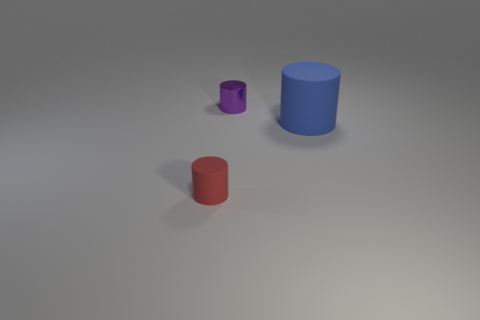Subtract all small shiny cylinders. How many cylinders are left? 2 Add 3 red rubber things. How many objects exist? 6 Subtract all brown cylinders. Subtract all yellow spheres. How many cylinders are left? 3 Add 1 tiny metallic cylinders. How many tiny metallic cylinders exist? 2 Subtract 0 gray cylinders. How many objects are left? 3 Subtract all purple metallic things. Subtract all red things. How many objects are left? 1 Add 2 blue rubber objects. How many blue rubber objects are left? 3 